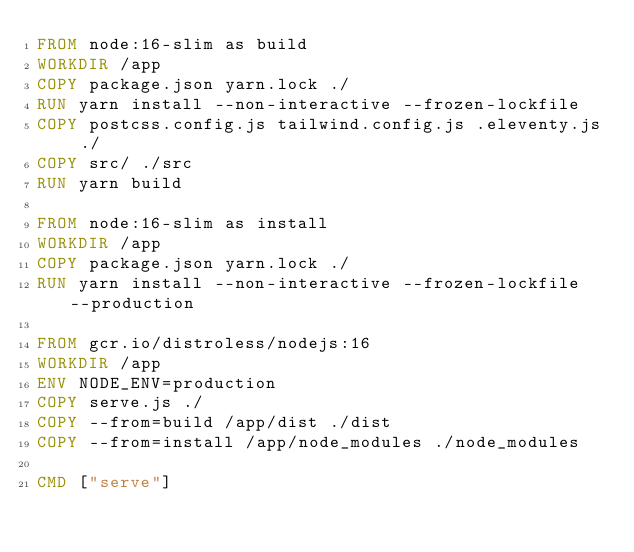<code> <loc_0><loc_0><loc_500><loc_500><_Dockerfile_>FROM node:16-slim as build
WORKDIR /app
COPY package.json yarn.lock ./
RUN yarn install --non-interactive --frozen-lockfile
COPY postcss.config.js tailwind.config.js .eleventy.js ./
COPY src/ ./src
RUN yarn build

FROM node:16-slim as install
WORKDIR /app
COPY package.json yarn.lock ./
RUN yarn install --non-interactive --frozen-lockfile --production

FROM gcr.io/distroless/nodejs:16
WORKDIR /app
ENV NODE_ENV=production
COPY serve.js ./
COPY --from=build /app/dist ./dist
COPY --from=install /app/node_modules ./node_modules

CMD ["serve"]
</code> 